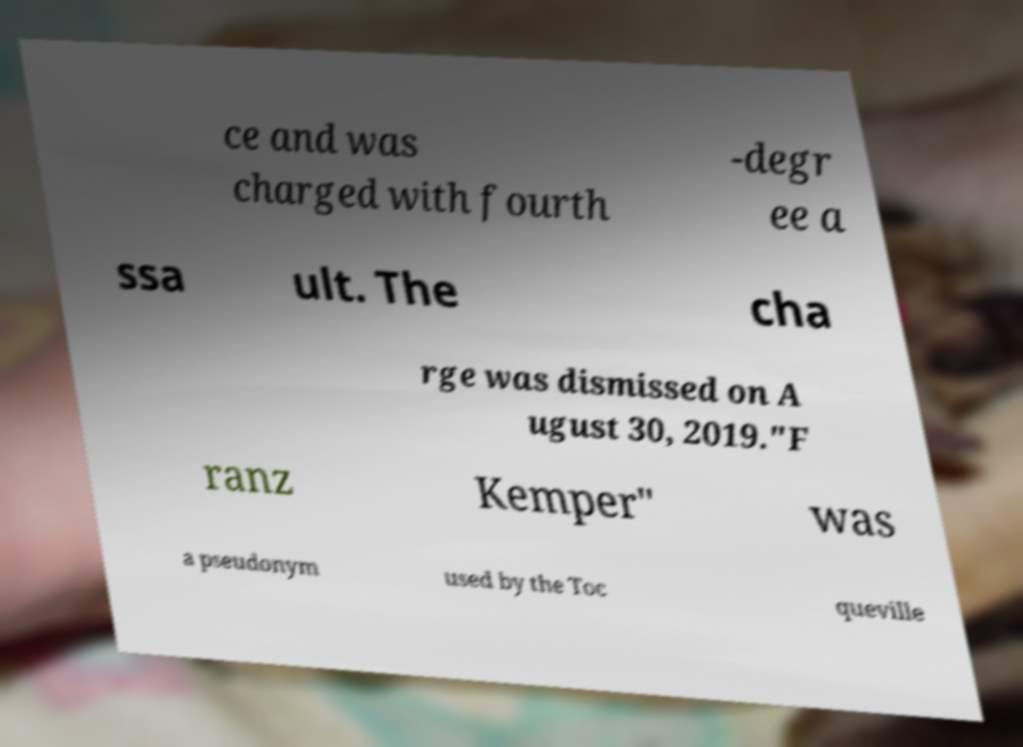There's text embedded in this image that I need extracted. Can you transcribe it verbatim? ce and was charged with fourth -degr ee a ssa ult. The cha rge was dismissed on A ugust 30, 2019."F ranz Kemper" was a pseudonym used by the Toc queville 